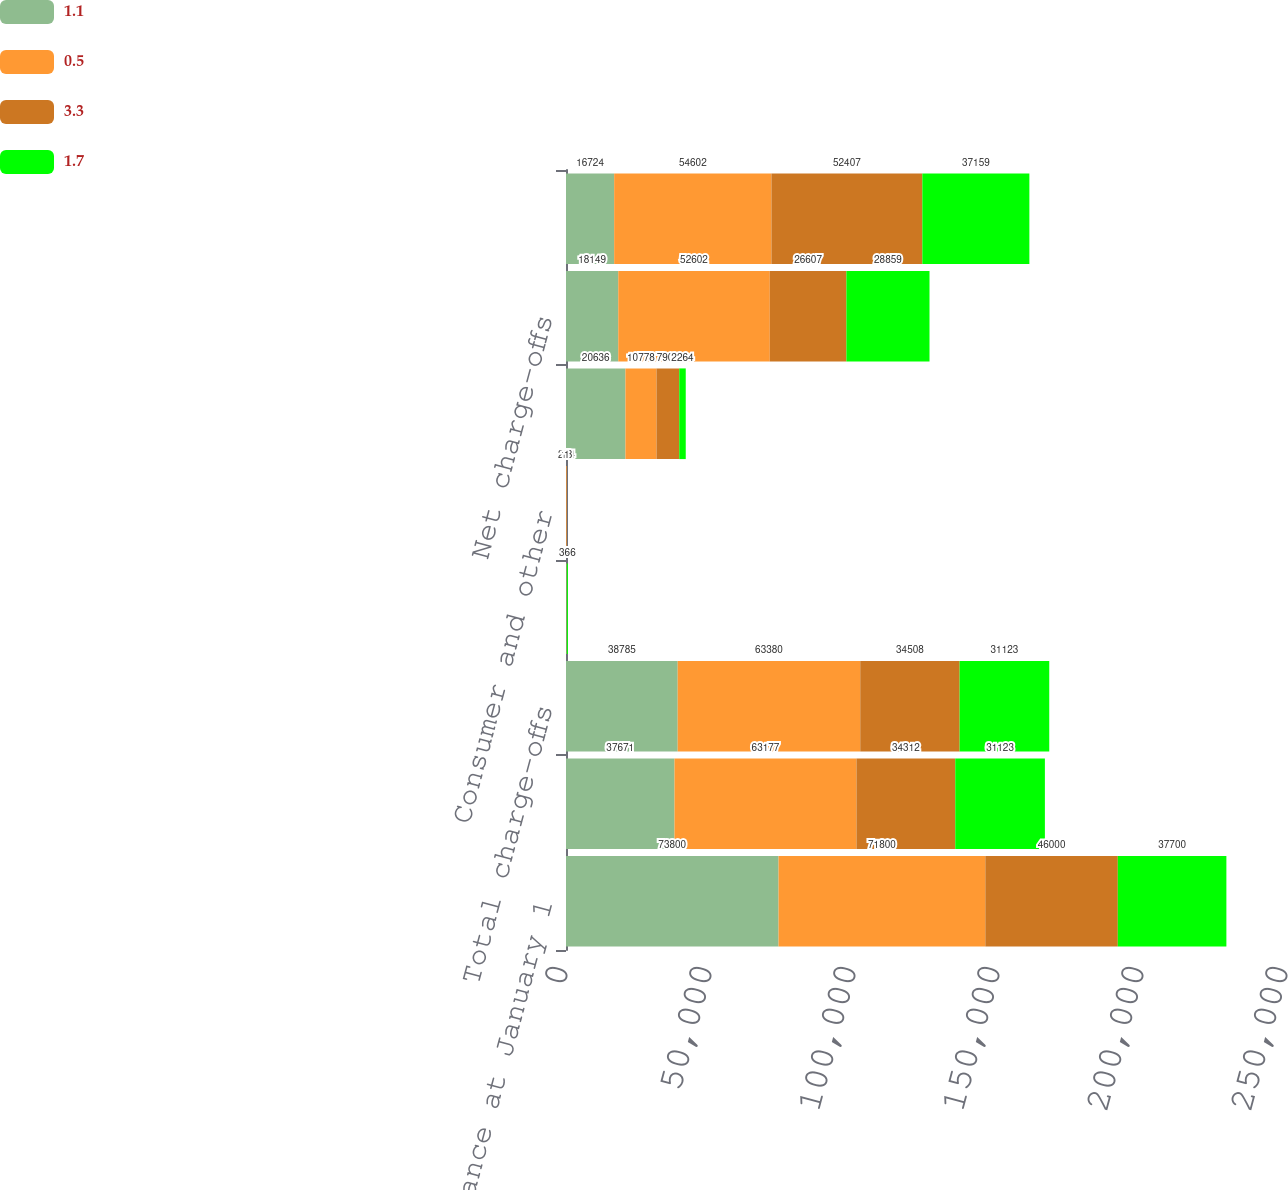Convert chart to OTSL. <chart><loc_0><loc_0><loc_500><loc_500><stacked_bar_chart><ecel><fcel>Balance at January 1<fcel>Commercial<fcel>Total charge-offs<fcel>Real estate<fcel>Consumer and other<fcel>Total recoveries<fcel>Net charge-offs<fcel>Provision for loan losses<nl><fcel>1.1<fcel>73800<fcel>37671<fcel>38785<fcel>209<fcel>19<fcel>20636<fcel>18149<fcel>16724<nl><fcel>0.5<fcel>71800<fcel>63177<fcel>63380<fcel>47<fcel>224<fcel>10778<fcel>52602<fcel>54602<nl><fcel>3.3<fcel>46000<fcel>34312<fcel>34508<fcel>34<fcel>18<fcel>7901<fcel>26607<fcel>52407<nl><fcel>1.7<fcel>37700<fcel>31123<fcel>31123<fcel>366<fcel>1<fcel>2264<fcel>28859<fcel>37159<nl></chart> 